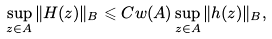<formula> <loc_0><loc_0><loc_500><loc_500>\sup _ { z \in A } \| H ( z ) \| _ { B } \leqslant C w ( A ) \sup _ { z \in A } \| h ( z ) \| _ { B } ,</formula> 